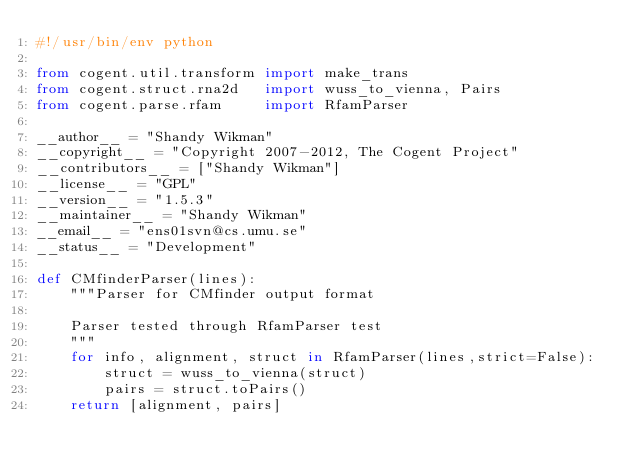Convert code to text. <code><loc_0><loc_0><loc_500><loc_500><_Python_>#!/usr/bin/env python

from cogent.util.transform import make_trans
from cogent.struct.rna2d   import wuss_to_vienna, Pairs
from cogent.parse.rfam     import RfamParser

__author__ = "Shandy Wikman"
__copyright__ = "Copyright 2007-2012, The Cogent Project"
__contributors__ = ["Shandy Wikman"]
__license__ = "GPL"
__version__ = "1.5.3"
__maintainer__ = "Shandy Wikman"
__email__ = "ens01svn@cs.umu.se"
__status__ = "Development"

def CMfinderParser(lines):
    """Parser for CMfinder output format

    Parser tested through RfamParser test
    """
    for info, alignment, struct in RfamParser(lines,strict=False):
        struct = wuss_to_vienna(struct)
        pairs = struct.toPairs()
    return [alignment, pairs]
    
</code> 